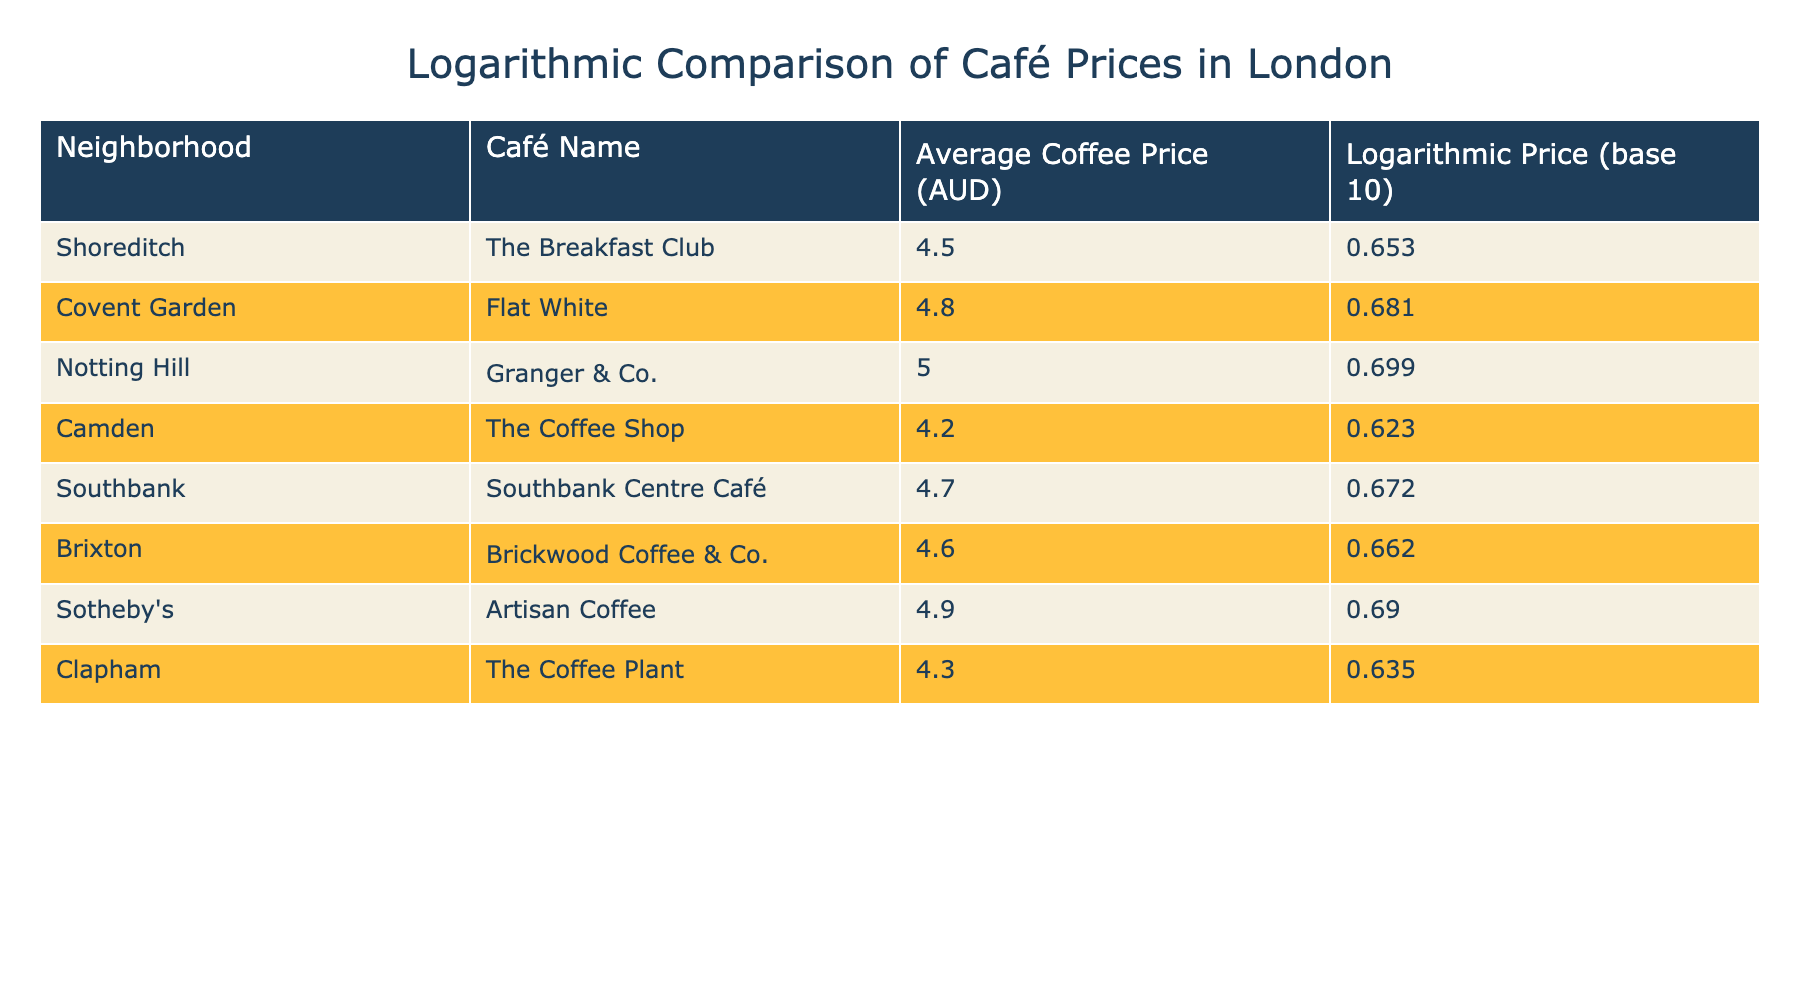What is the average coffee price at Notting Hill's café? The table shows that the average coffee price at Notting Hill's café, Granger & Co., is 5.00 AUD which is listed directly in the Average Coffee Price column.
Answer: 5.00 AUD Which neighborhood has the highest logarithmic coffee price? Comparing the logarithmic prices listed in the table, Notting Hill (0.699) has the highest value, followed by Sotheby's (0.690).
Answer: Notting Hill What is the difference between the lowest and highest average coffee prices in the table? The lowest average coffee price is in Camden (4.20 AUD) and the highest is in Notting Hill (5.00 AUD). The difference is calculated as 5.00 - 4.20 = 0.80 AUD.
Answer: 0.80 AUD Is the average coffee price at Brixton less than the average coffee price at Clapham? Brixton's average coffee price is 4.60 AUD and Clapham's is 4.30 AUD. Since 4.60 is greater than 4.30, the statement is false.
Answer: No What is the average logarithmic price for cafés in Shoreditch and Camden? The logarithmic price for Shoreditch is 0.653 and for Camden is 0.623. To find the average, sum both values (0.653 + 0.623 = 1.276) and divide by 2, yielding an average of 1.276 / 2 = 0.638.
Answer: 0.638 Which café has an average price closest to the overall average of the coffees listed? First, calculate the overall average of all average prices: (4.50 + 4.80 + 5.00 + 4.20 + 4.70 + 4.60 + 4.90 + 4.30) / 8 = 4.589. The café with the closest price is Brixton (4.60 AUD).
Answer: Brickwood Coffee & Co. (Brixton) Is it true that all cafés in Covent Garden have an average price above 4.60 AUD? The only café listed for Covent Garden is Flat White with an average price of 4.80 AUD, which is above 4.60 AUD, thus the statement is true.
Answer: Yes Which neighbhorhood has a lower average coffee price, Southbank or Brixton? Southbank's café average is 4.70 AUD and Brixton's is 4.60 AUD. Comparing these, Brixton has a lower price compared to Southbank.
Answer: Brixton 